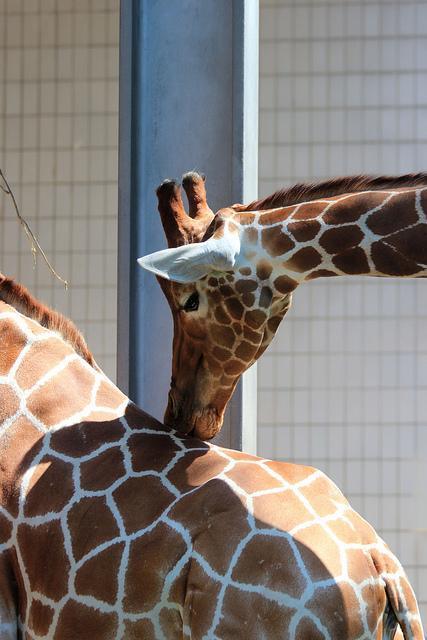How many giraffes are there?
Give a very brief answer. 2. How many giraffes are in the photo?
Give a very brief answer. 2. 